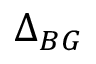<formula> <loc_0><loc_0><loc_500><loc_500>\Delta _ { B G }</formula> 